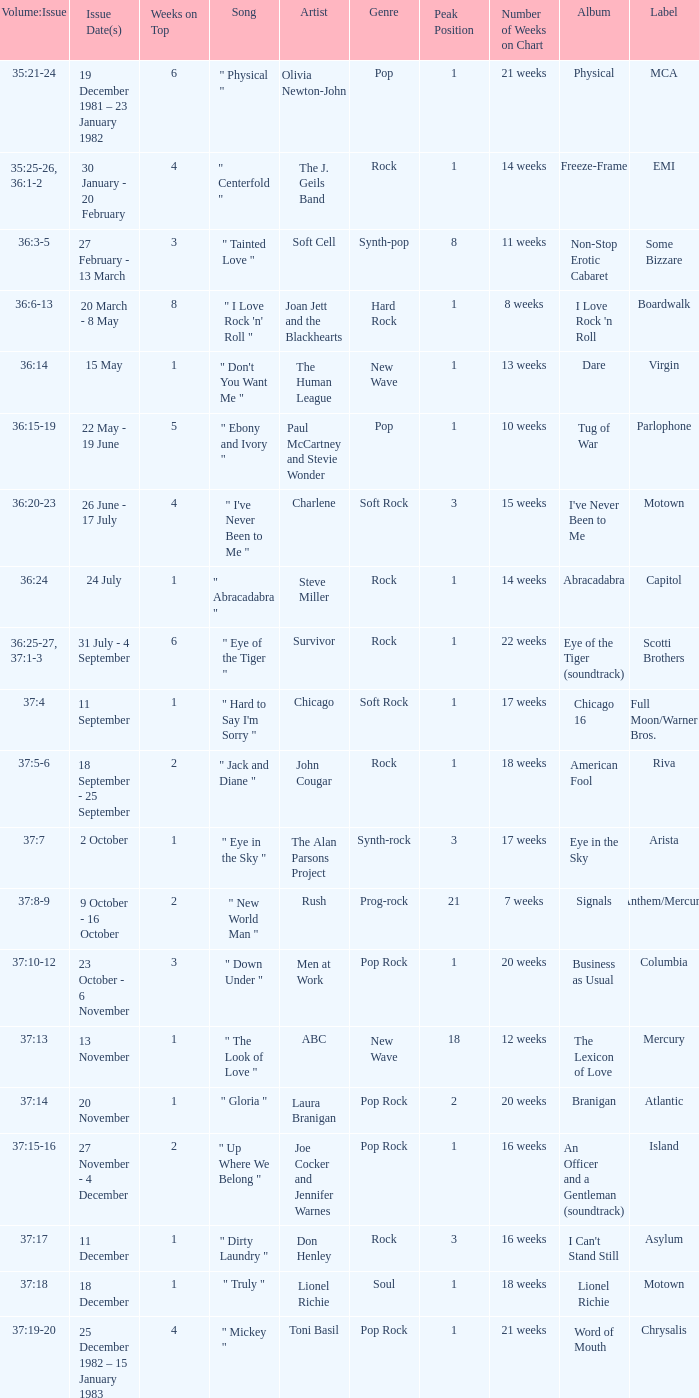Which Issue Date(s) has Weeks on Top larger than 3, and a Volume: Issue of 35:25-26, 36:1-2? 30 January - 20 February. 